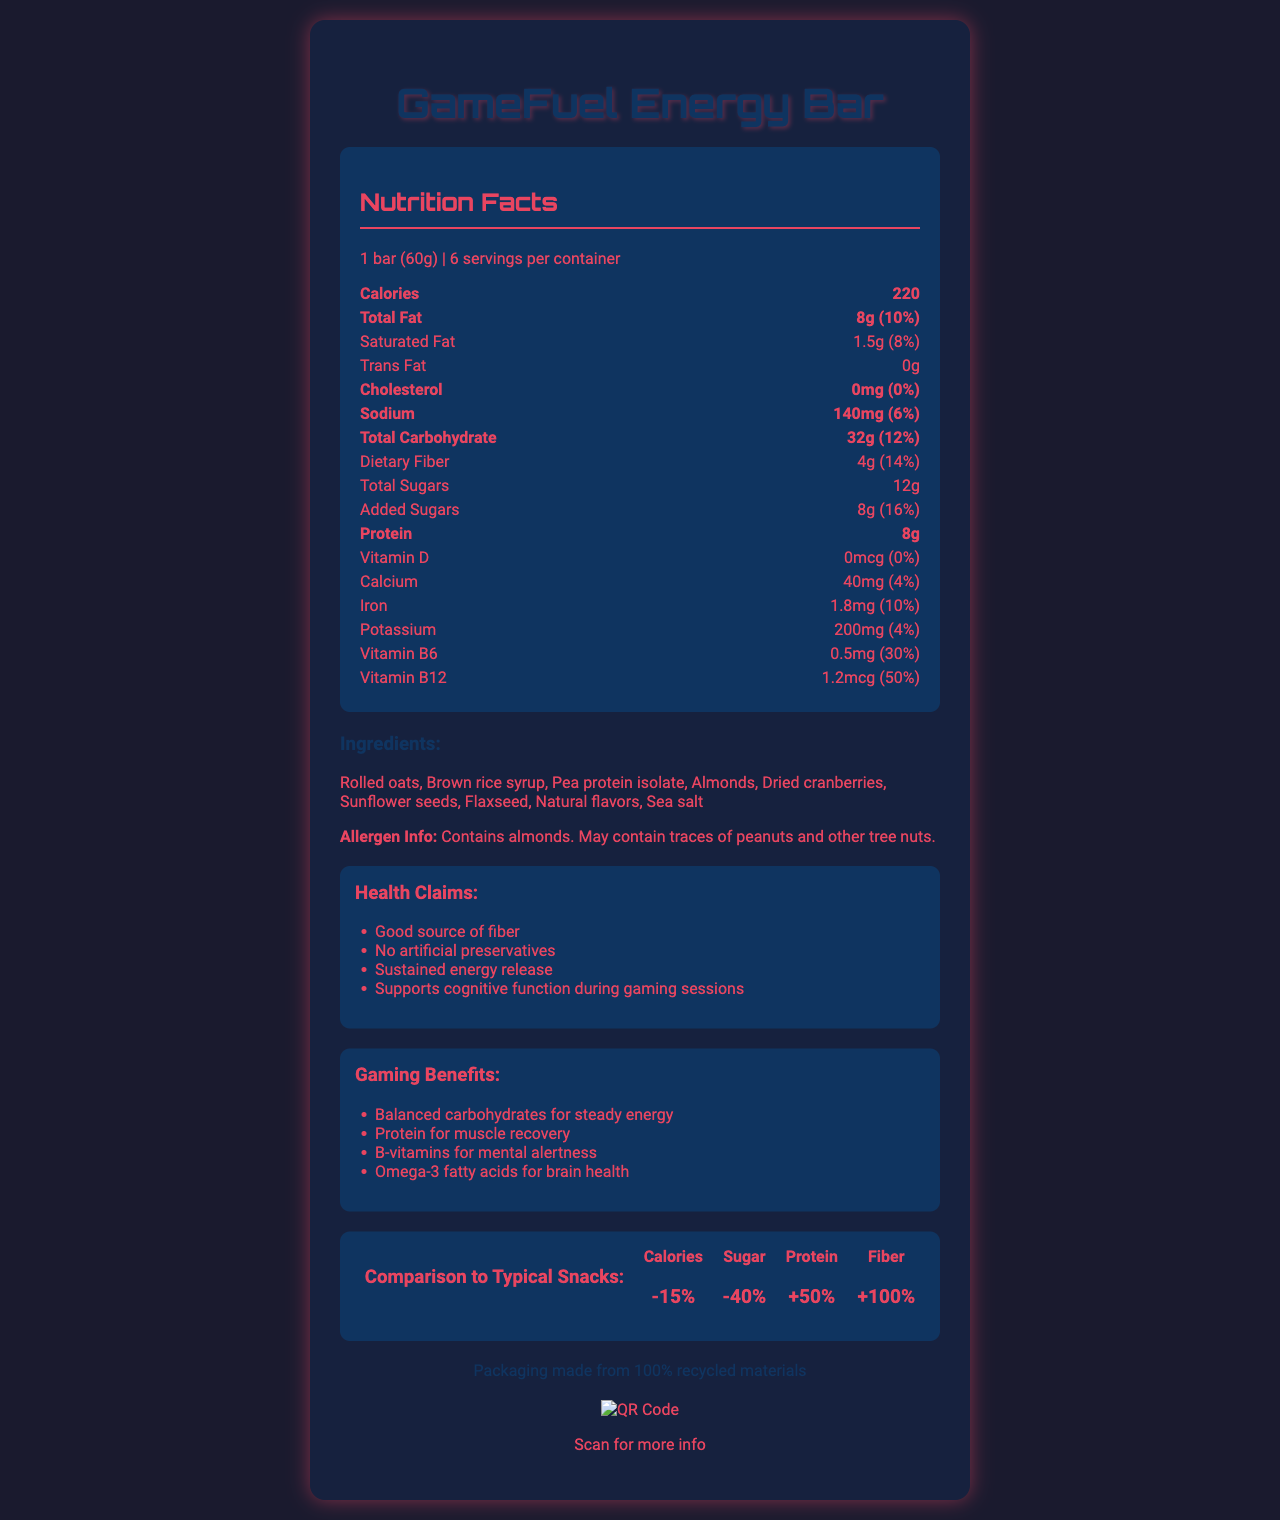what is the serving size of the GameFuel Energy Bar? The serving size is explicitly mentioned as "1 bar (60g)" in the nutrition facts section.
Answer: 1 bar (60g) how many servings per container are there? The document states that there are 6 servings per container.
Answer: 6 how much protein does one serving of the GameFuel Energy Bar contain? The protein amount per serving is listed as 8g in the nutrition facts section.
Answer: 8g what percentage of daily value does Vitamin B12 provide? The daily value for Vitamin B12 is mentioned as 50% per serving.
Answer: 50% which ingredient is most likely to cause allergies? The allergen information section explicitly states that the product contains almonds and may contain traces of peanuts and other tree nuts.
Answer: Almonds what is the total fat content per serving? The total fat content is listed as 8g per serving in the nutrition facts section.
Answer: 8g which of the following health claims is made about the GameFuel Energy Bar? A. Strengthens bones B. Good source of fiber C. Supports heart health "Good source of fiber" is listed in the health claims section, while the other options are not mentioned in the document.
Answer: B. Good source of fiber which of the following benefits is related to gaming? I. Balanced carbohydrates for steady energy II. Protein for muscle recovery III. Vitamin C for immune support Both "Balanced carbohydrates for steady energy" and "Protein for muscle recovery" are listed under gaming benefits, whereas Vitamin C for immune support is not mentioned.
Answer: I and II does the document mention the presence of trans fat in the GameFuel Energy Bar? The nutrition facts section states that the bar contains 0g of trans fat, meaning trans fat is not present.
Answer: No summarize the main idea of the document. The document presents the nutrition facts, health claims, and gaming benefits of the GameFuel Energy Bar, stressing its ingredients, allergen information, and eco-friendly packaging. It also compares the product to typical snacks to showcase its advantages for long gaming sessions.
Answer: The document provides detailed nutrition information for the GameFuel Energy Bar, highlighting its benefits, ingredients, health claims, and its suitability for gamers through sustained energy release. It emphasizes its comparative advantage over typical snacks and includes sustainability information. how much dietary fiber does the GameFuel Energy Bar have compared to typical snacks? The comparison to typical snacks section indicates that the dietary fiber content is 100% higher than typical snacks.
Answer: +100% how many milligrams of calcium does one serving contain? A. 40mg B. 140mg C. 200mg D. 1.8mg The document lists the calcium amount per serving as 40mg in the nutrition facts section.
Answer: A. 40mg can the amount of Omega-3 fatty acids in the GameFuel Energy Bar be determined from the document? The document does not provide any specific information on the amount of Omega-3 fatty acids contained in the bar.
Answer: Cannot be determined does the GameFuel Energy Bar contain any artificial preservatives? The health claims section states "No artificial preservatives", indicating that the bar does not contain any.
Answer: No 